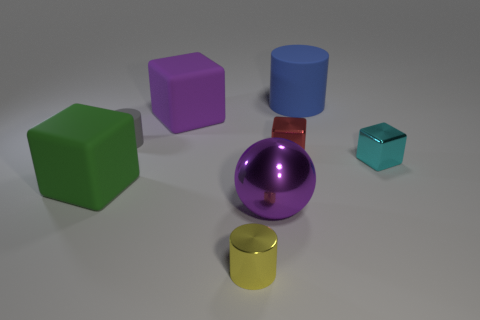Add 2 tiny metallic spheres. How many objects exist? 10 Subtract all cylinders. How many objects are left? 5 Subtract 0 brown blocks. How many objects are left? 8 Subtract all blue rubber cylinders. Subtract all tiny cylinders. How many objects are left? 5 Add 4 yellow shiny things. How many yellow shiny things are left? 5 Add 4 large blue rubber cylinders. How many large blue rubber cylinders exist? 5 